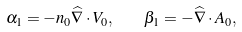Convert formula to latex. <formula><loc_0><loc_0><loc_500><loc_500>\alpha _ { 1 } = - n _ { 0 } { \widehat { \nabla } } \cdot { V } _ { 0 } , \quad \beta _ { 1 } = - { \widehat { \nabla } } \cdot { A } _ { 0 } ,</formula> 